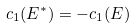Convert formula to latex. <formula><loc_0><loc_0><loc_500><loc_500>c _ { 1 } ( E ^ { * } ) = - c _ { 1 } ( E )</formula> 